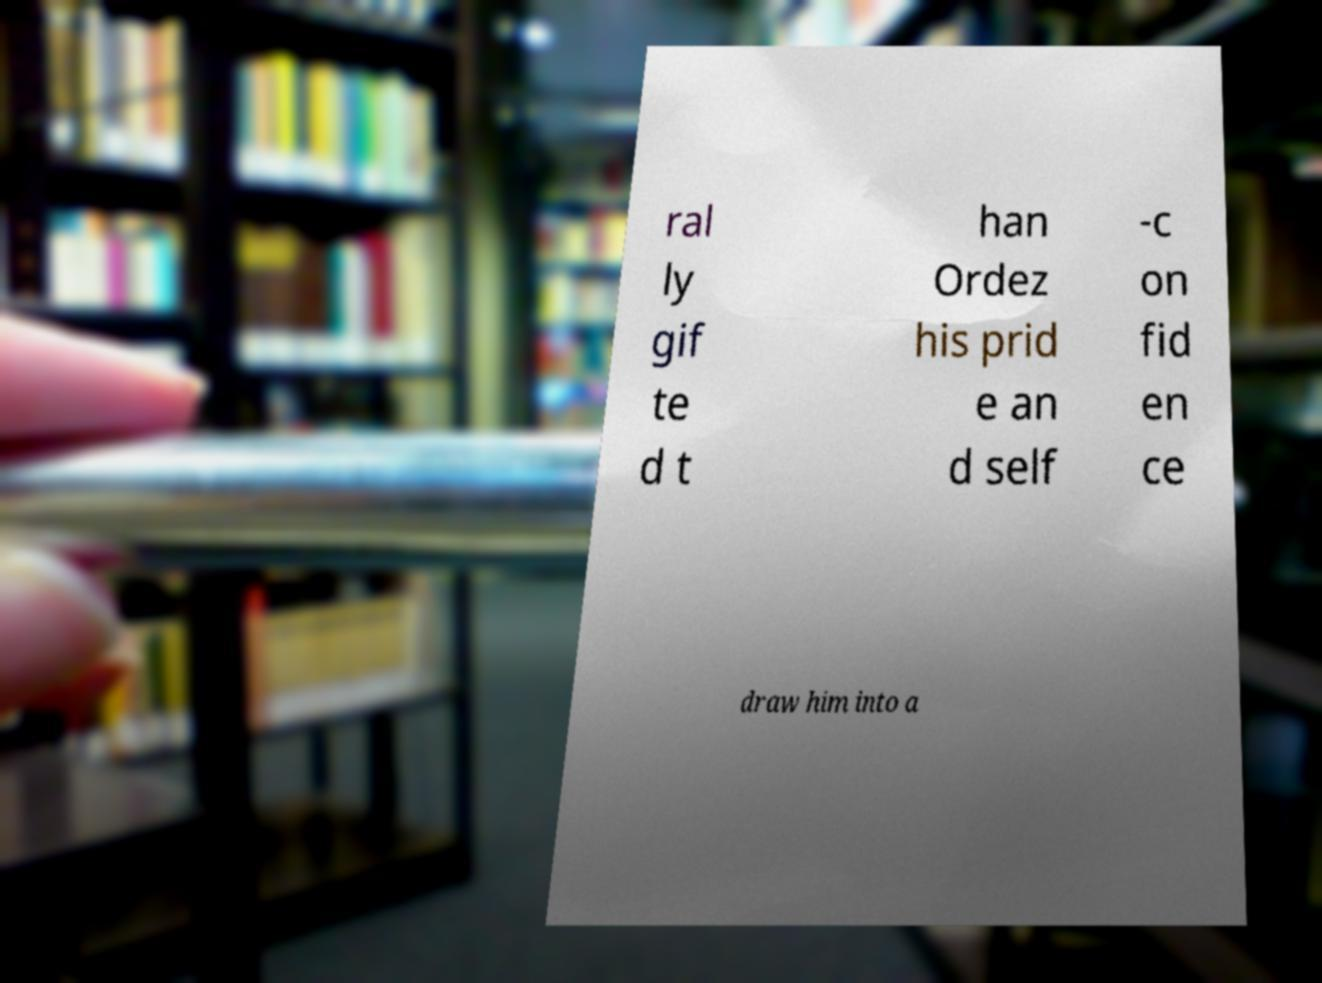Can you read and provide the text displayed in the image?This photo seems to have some interesting text. Can you extract and type it out for me? ral ly gif te d t han Ordez his prid e an d self -c on fid en ce draw him into a 